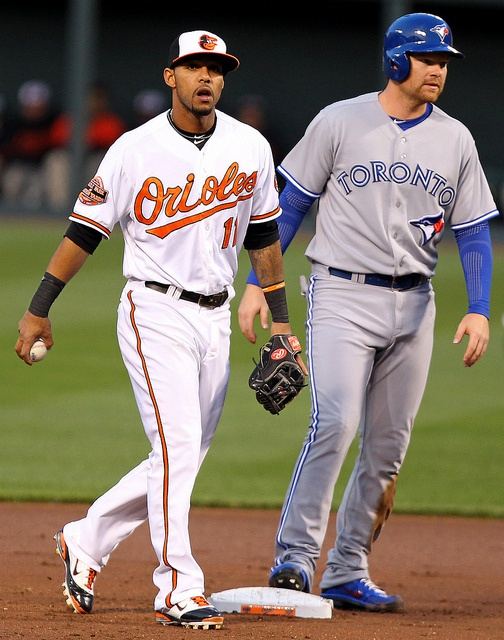Describe the objects in this image and their specific colors. I can see people in black, lavender, brown, and darkgray tones, people in black, darkgray, lightgray, and gray tones, people in black, gray, and maroon tones, baseball glove in black, gray, and olive tones, and people in black and gray tones in this image. 